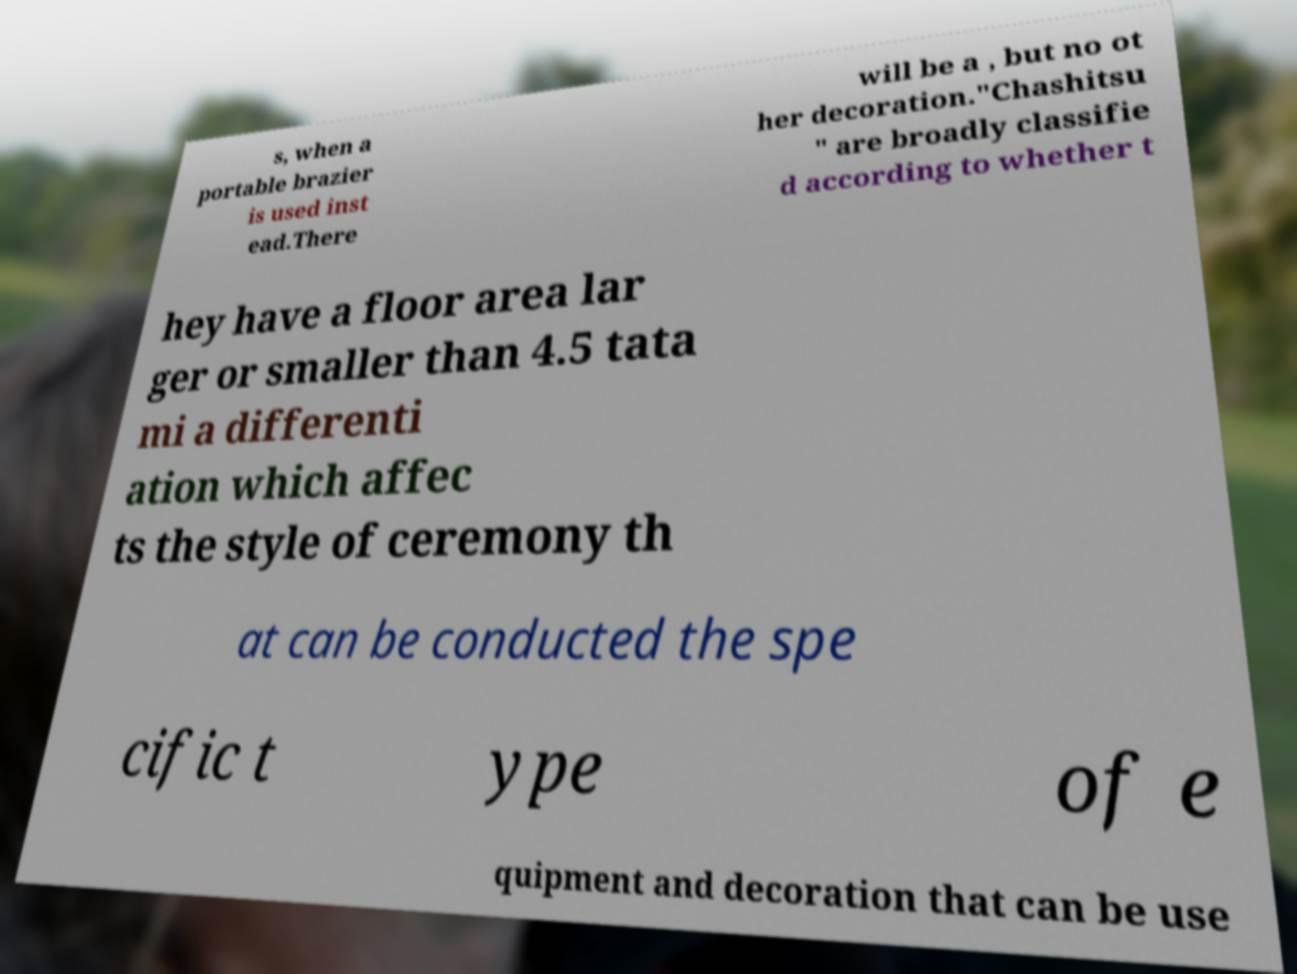Please identify and transcribe the text found in this image. s, when a portable brazier is used inst ead.There will be a , but no ot her decoration."Chashitsu " are broadly classifie d according to whether t hey have a floor area lar ger or smaller than 4.5 tata mi a differenti ation which affec ts the style of ceremony th at can be conducted the spe cific t ype of e quipment and decoration that can be use 